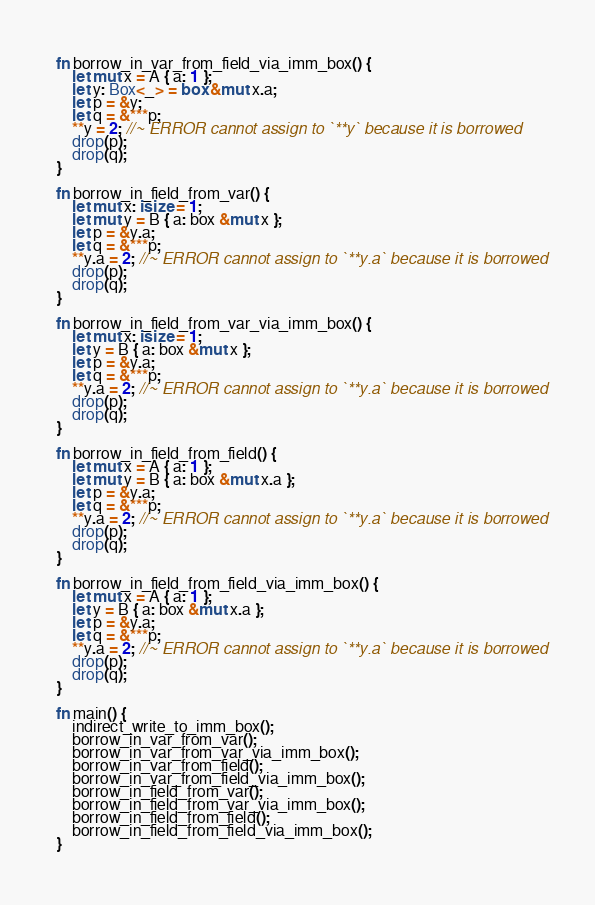<code> <loc_0><loc_0><loc_500><loc_500><_Rust_>
fn borrow_in_var_from_field_via_imm_box() {
    let mut x = A { a: 1 };
    let y: Box<_> = box &mut x.a;
    let p = &y;
    let q = &***p;
    **y = 2; //~ ERROR cannot assign to `**y` because it is borrowed
    drop(p);
    drop(q);
}

fn borrow_in_field_from_var() {
    let mut x: isize = 1;
    let mut y = B { a: box &mut x };
    let p = &y.a;
    let q = &***p;
    **y.a = 2; //~ ERROR cannot assign to `**y.a` because it is borrowed
    drop(p);
    drop(q);
}

fn borrow_in_field_from_var_via_imm_box() {
    let mut x: isize = 1;
    let y = B { a: box &mut x };
    let p = &y.a;
    let q = &***p;
    **y.a = 2; //~ ERROR cannot assign to `**y.a` because it is borrowed
    drop(p);
    drop(q);
}

fn borrow_in_field_from_field() {
    let mut x = A { a: 1 };
    let mut y = B { a: box &mut x.a };
    let p = &y.a;
    let q = &***p;
    **y.a = 2; //~ ERROR cannot assign to `**y.a` because it is borrowed
    drop(p);
    drop(q);
}

fn borrow_in_field_from_field_via_imm_box() {
    let mut x = A { a: 1 };
    let y = B { a: box &mut x.a };
    let p = &y.a;
    let q = &***p;
    **y.a = 2; //~ ERROR cannot assign to `**y.a` because it is borrowed
    drop(p);
    drop(q);
}

fn main() {
    indirect_write_to_imm_box();
    borrow_in_var_from_var();
    borrow_in_var_from_var_via_imm_box();
    borrow_in_var_from_field();
    borrow_in_var_from_field_via_imm_box();
    borrow_in_field_from_var();
    borrow_in_field_from_var_via_imm_box();
    borrow_in_field_from_field();
    borrow_in_field_from_field_via_imm_box();
}
</code> 